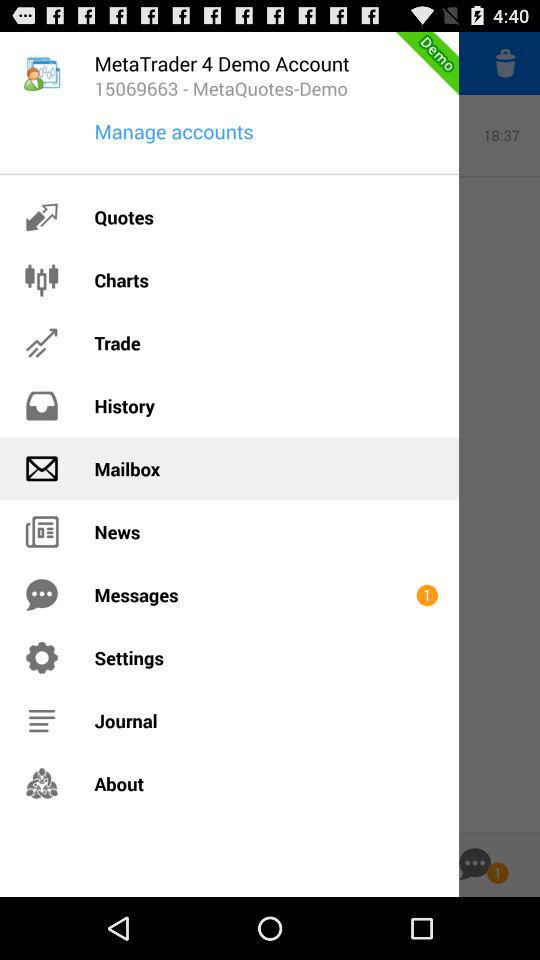Which item is selected? The selected item is "Mailbox". 